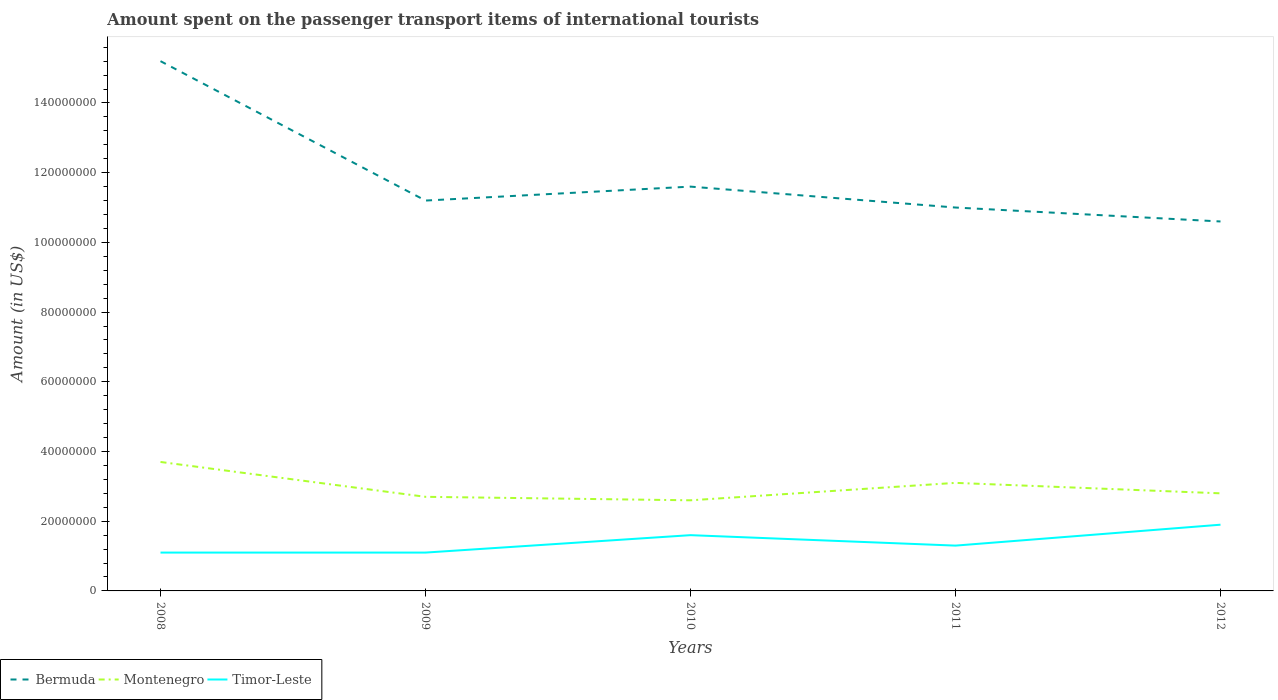How many different coloured lines are there?
Give a very brief answer. 3. Across all years, what is the maximum amount spent on the passenger transport items of international tourists in Montenegro?
Offer a terse response. 2.60e+07. What is the difference between the highest and the second highest amount spent on the passenger transport items of international tourists in Montenegro?
Ensure brevity in your answer.  1.10e+07. Is the amount spent on the passenger transport items of international tourists in Timor-Leste strictly greater than the amount spent on the passenger transport items of international tourists in Bermuda over the years?
Offer a terse response. Yes. How many lines are there?
Keep it short and to the point. 3. Are the values on the major ticks of Y-axis written in scientific E-notation?
Your response must be concise. No. Does the graph contain any zero values?
Make the answer very short. No. Does the graph contain grids?
Your answer should be compact. No. How are the legend labels stacked?
Provide a short and direct response. Horizontal. What is the title of the graph?
Provide a succinct answer. Amount spent on the passenger transport items of international tourists. Does "Ethiopia" appear as one of the legend labels in the graph?
Provide a short and direct response. No. What is the label or title of the Y-axis?
Make the answer very short. Amount (in US$). What is the Amount (in US$) in Bermuda in 2008?
Your answer should be very brief. 1.52e+08. What is the Amount (in US$) in Montenegro in 2008?
Make the answer very short. 3.70e+07. What is the Amount (in US$) in Timor-Leste in 2008?
Keep it short and to the point. 1.10e+07. What is the Amount (in US$) in Bermuda in 2009?
Your answer should be very brief. 1.12e+08. What is the Amount (in US$) in Montenegro in 2009?
Provide a short and direct response. 2.70e+07. What is the Amount (in US$) in Timor-Leste in 2009?
Your answer should be very brief. 1.10e+07. What is the Amount (in US$) of Bermuda in 2010?
Offer a terse response. 1.16e+08. What is the Amount (in US$) in Montenegro in 2010?
Provide a short and direct response. 2.60e+07. What is the Amount (in US$) of Timor-Leste in 2010?
Provide a short and direct response. 1.60e+07. What is the Amount (in US$) of Bermuda in 2011?
Provide a succinct answer. 1.10e+08. What is the Amount (in US$) of Montenegro in 2011?
Your response must be concise. 3.10e+07. What is the Amount (in US$) of Timor-Leste in 2011?
Your answer should be very brief. 1.30e+07. What is the Amount (in US$) in Bermuda in 2012?
Give a very brief answer. 1.06e+08. What is the Amount (in US$) of Montenegro in 2012?
Your answer should be very brief. 2.80e+07. What is the Amount (in US$) in Timor-Leste in 2012?
Give a very brief answer. 1.90e+07. Across all years, what is the maximum Amount (in US$) in Bermuda?
Your response must be concise. 1.52e+08. Across all years, what is the maximum Amount (in US$) of Montenegro?
Your answer should be compact. 3.70e+07. Across all years, what is the maximum Amount (in US$) in Timor-Leste?
Ensure brevity in your answer.  1.90e+07. Across all years, what is the minimum Amount (in US$) of Bermuda?
Your response must be concise. 1.06e+08. Across all years, what is the minimum Amount (in US$) of Montenegro?
Make the answer very short. 2.60e+07. Across all years, what is the minimum Amount (in US$) in Timor-Leste?
Give a very brief answer. 1.10e+07. What is the total Amount (in US$) of Bermuda in the graph?
Your answer should be very brief. 5.96e+08. What is the total Amount (in US$) in Montenegro in the graph?
Make the answer very short. 1.49e+08. What is the total Amount (in US$) of Timor-Leste in the graph?
Keep it short and to the point. 7.00e+07. What is the difference between the Amount (in US$) in Bermuda in 2008 and that in 2009?
Offer a terse response. 4.00e+07. What is the difference between the Amount (in US$) in Montenegro in 2008 and that in 2009?
Your response must be concise. 1.00e+07. What is the difference between the Amount (in US$) of Bermuda in 2008 and that in 2010?
Provide a short and direct response. 3.60e+07. What is the difference between the Amount (in US$) in Montenegro in 2008 and that in 2010?
Your answer should be very brief. 1.10e+07. What is the difference between the Amount (in US$) of Timor-Leste in 2008 and that in 2010?
Give a very brief answer. -5.00e+06. What is the difference between the Amount (in US$) in Bermuda in 2008 and that in 2011?
Your answer should be very brief. 4.20e+07. What is the difference between the Amount (in US$) in Montenegro in 2008 and that in 2011?
Your answer should be very brief. 6.00e+06. What is the difference between the Amount (in US$) in Bermuda in 2008 and that in 2012?
Your answer should be compact. 4.60e+07. What is the difference between the Amount (in US$) in Montenegro in 2008 and that in 2012?
Keep it short and to the point. 9.00e+06. What is the difference between the Amount (in US$) of Timor-Leste in 2008 and that in 2012?
Your answer should be very brief. -8.00e+06. What is the difference between the Amount (in US$) of Bermuda in 2009 and that in 2010?
Provide a short and direct response. -4.00e+06. What is the difference between the Amount (in US$) of Montenegro in 2009 and that in 2010?
Keep it short and to the point. 1.00e+06. What is the difference between the Amount (in US$) of Timor-Leste in 2009 and that in 2010?
Your response must be concise. -5.00e+06. What is the difference between the Amount (in US$) in Montenegro in 2009 and that in 2011?
Keep it short and to the point. -4.00e+06. What is the difference between the Amount (in US$) in Timor-Leste in 2009 and that in 2011?
Ensure brevity in your answer.  -2.00e+06. What is the difference between the Amount (in US$) of Timor-Leste in 2009 and that in 2012?
Your answer should be very brief. -8.00e+06. What is the difference between the Amount (in US$) in Montenegro in 2010 and that in 2011?
Offer a very short reply. -5.00e+06. What is the difference between the Amount (in US$) of Timor-Leste in 2010 and that in 2011?
Your response must be concise. 3.00e+06. What is the difference between the Amount (in US$) of Bermuda in 2010 and that in 2012?
Offer a very short reply. 1.00e+07. What is the difference between the Amount (in US$) in Montenegro in 2010 and that in 2012?
Give a very brief answer. -2.00e+06. What is the difference between the Amount (in US$) of Timor-Leste in 2010 and that in 2012?
Make the answer very short. -3.00e+06. What is the difference between the Amount (in US$) of Bermuda in 2011 and that in 2012?
Ensure brevity in your answer.  4.00e+06. What is the difference between the Amount (in US$) in Montenegro in 2011 and that in 2012?
Provide a short and direct response. 3.00e+06. What is the difference between the Amount (in US$) of Timor-Leste in 2011 and that in 2012?
Make the answer very short. -6.00e+06. What is the difference between the Amount (in US$) of Bermuda in 2008 and the Amount (in US$) of Montenegro in 2009?
Your answer should be compact. 1.25e+08. What is the difference between the Amount (in US$) in Bermuda in 2008 and the Amount (in US$) in Timor-Leste in 2009?
Your answer should be compact. 1.41e+08. What is the difference between the Amount (in US$) in Montenegro in 2008 and the Amount (in US$) in Timor-Leste in 2009?
Offer a very short reply. 2.60e+07. What is the difference between the Amount (in US$) in Bermuda in 2008 and the Amount (in US$) in Montenegro in 2010?
Keep it short and to the point. 1.26e+08. What is the difference between the Amount (in US$) of Bermuda in 2008 and the Amount (in US$) of Timor-Leste in 2010?
Offer a very short reply. 1.36e+08. What is the difference between the Amount (in US$) of Montenegro in 2008 and the Amount (in US$) of Timor-Leste in 2010?
Your answer should be compact. 2.10e+07. What is the difference between the Amount (in US$) of Bermuda in 2008 and the Amount (in US$) of Montenegro in 2011?
Offer a very short reply. 1.21e+08. What is the difference between the Amount (in US$) in Bermuda in 2008 and the Amount (in US$) in Timor-Leste in 2011?
Make the answer very short. 1.39e+08. What is the difference between the Amount (in US$) of Montenegro in 2008 and the Amount (in US$) of Timor-Leste in 2011?
Make the answer very short. 2.40e+07. What is the difference between the Amount (in US$) in Bermuda in 2008 and the Amount (in US$) in Montenegro in 2012?
Your answer should be compact. 1.24e+08. What is the difference between the Amount (in US$) in Bermuda in 2008 and the Amount (in US$) in Timor-Leste in 2012?
Keep it short and to the point. 1.33e+08. What is the difference between the Amount (in US$) of Montenegro in 2008 and the Amount (in US$) of Timor-Leste in 2012?
Keep it short and to the point. 1.80e+07. What is the difference between the Amount (in US$) of Bermuda in 2009 and the Amount (in US$) of Montenegro in 2010?
Provide a succinct answer. 8.60e+07. What is the difference between the Amount (in US$) of Bermuda in 2009 and the Amount (in US$) of Timor-Leste in 2010?
Keep it short and to the point. 9.60e+07. What is the difference between the Amount (in US$) in Montenegro in 2009 and the Amount (in US$) in Timor-Leste in 2010?
Keep it short and to the point. 1.10e+07. What is the difference between the Amount (in US$) of Bermuda in 2009 and the Amount (in US$) of Montenegro in 2011?
Offer a terse response. 8.10e+07. What is the difference between the Amount (in US$) of Bermuda in 2009 and the Amount (in US$) of Timor-Leste in 2011?
Keep it short and to the point. 9.90e+07. What is the difference between the Amount (in US$) in Montenegro in 2009 and the Amount (in US$) in Timor-Leste in 2011?
Make the answer very short. 1.40e+07. What is the difference between the Amount (in US$) of Bermuda in 2009 and the Amount (in US$) of Montenegro in 2012?
Ensure brevity in your answer.  8.40e+07. What is the difference between the Amount (in US$) of Bermuda in 2009 and the Amount (in US$) of Timor-Leste in 2012?
Provide a succinct answer. 9.30e+07. What is the difference between the Amount (in US$) of Bermuda in 2010 and the Amount (in US$) of Montenegro in 2011?
Keep it short and to the point. 8.50e+07. What is the difference between the Amount (in US$) in Bermuda in 2010 and the Amount (in US$) in Timor-Leste in 2011?
Your response must be concise. 1.03e+08. What is the difference between the Amount (in US$) in Montenegro in 2010 and the Amount (in US$) in Timor-Leste in 2011?
Give a very brief answer. 1.30e+07. What is the difference between the Amount (in US$) in Bermuda in 2010 and the Amount (in US$) in Montenegro in 2012?
Your answer should be compact. 8.80e+07. What is the difference between the Amount (in US$) in Bermuda in 2010 and the Amount (in US$) in Timor-Leste in 2012?
Keep it short and to the point. 9.70e+07. What is the difference between the Amount (in US$) of Montenegro in 2010 and the Amount (in US$) of Timor-Leste in 2012?
Keep it short and to the point. 7.00e+06. What is the difference between the Amount (in US$) in Bermuda in 2011 and the Amount (in US$) in Montenegro in 2012?
Your answer should be very brief. 8.20e+07. What is the difference between the Amount (in US$) in Bermuda in 2011 and the Amount (in US$) in Timor-Leste in 2012?
Ensure brevity in your answer.  9.10e+07. What is the difference between the Amount (in US$) of Montenegro in 2011 and the Amount (in US$) of Timor-Leste in 2012?
Give a very brief answer. 1.20e+07. What is the average Amount (in US$) of Bermuda per year?
Offer a terse response. 1.19e+08. What is the average Amount (in US$) in Montenegro per year?
Offer a terse response. 2.98e+07. What is the average Amount (in US$) in Timor-Leste per year?
Provide a short and direct response. 1.40e+07. In the year 2008, what is the difference between the Amount (in US$) of Bermuda and Amount (in US$) of Montenegro?
Ensure brevity in your answer.  1.15e+08. In the year 2008, what is the difference between the Amount (in US$) in Bermuda and Amount (in US$) in Timor-Leste?
Ensure brevity in your answer.  1.41e+08. In the year 2008, what is the difference between the Amount (in US$) in Montenegro and Amount (in US$) in Timor-Leste?
Offer a terse response. 2.60e+07. In the year 2009, what is the difference between the Amount (in US$) in Bermuda and Amount (in US$) in Montenegro?
Ensure brevity in your answer.  8.50e+07. In the year 2009, what is the difference between the Amount (in US$) of Bermuda and Amount (in US$) of Timor-Leste?
Keep it short and to the point. 1.01e+08. In the year 2009, what is the difference between the Amount (in US$) of Montenegro and Amount (in US$) of Timor-Leste?
Give a very brief answer. 1.60e+07. In the year 2010, what is the difference between the Amount (in US$) in Bermuda and Amount (in US$) in Montenegro?
Provide a short and direct response. 9.00e+07. In the year 2010, what is the difference between the Amount (in US$) of Montenegro and Amount (in US$) of Timor-Leste?
Offer a terse response. 1.00e+07. In the year 2011, what is the difference between the Amount (in US$) in Bermuda and Amount (in US$) in Montenegro?
Keep it short and to the point. 7.90e+07. In the year 2011, what is the difference between the Amount (in US$) of Bermuda and Amount (in US$) of Timor-Leste?
Make the answer very short. 9.70e+07. In the year 2011, what is the difference between the Amount (in US$) in Montenegro and Amount (in US$) in Timor-Leste?
Your answer should be very brief. 1.80e+07. In the year 2012, what is the difference between the Amount (in US$) in Bermuda and Amount (in US$) in Montenegro?
Your response must be concise. 7.80e+07. In the year 2012, what is the difference between the Amount (in US$) in Bermuda and Amount (in US$) in Timor-Leste?
Make the answer very short. 8.70e+07. In the year 2012, what is the difference between the Amount (in US$) in Montenegro and Amount (in US$) in Timor-Leste?
Offer a terse response. 9.00e+06. What is the ratio of the Amount (in US$) of Bermuda in 2008 to that in 2009?
Offer a terse response. 1.36. What is the ratio of the Amount (in US$) in Montenegro in 2008 to that in 2009?
Offer a terse response. 1.37. What is the ratio of the Amount (in US$) in Timor-Leste in 2008 to that in 2009?
Offer a terse response. 1. What is the ratio of the Amount (in US$) in Bermuda in 2008 to that in 2010?
Offer a very short reply. 1.31. What is the ratio of the Amount (in US$) in Montenegro in 2008 to that in 2010?
Provide a succinct answer. 1.42. What is the ratio of the Amount (in US$) in Timor-Leste in 2008 to that in 2010?
Provide a short and direct response. 0.69. What is the ratio of the Amount (in US$) of Bermuda in 2008 to that in 2011?
Your answer should be compact. 1.38. What is the ratio of the Amount (in US$) in Montenegro in 2008 to that in 2011?
Offer a terse response. 1.19. What is the ratio of the Amount (in US$) of Timor-Leste in 2008 to that in 2011?
Make the answer very short. 0.85. What is the ratio of the Amount (in US$) in Bermuda in 2008 to that in 2012?
Offer a terse response. 1.43. What is the ratio of the Amount (in US$) of Montenegro in 2008 to that in 2012?
Offer a terse response. 1.32. What is the ratio of the Amount (in US$) in Timor-Leste in 2008 to that in 2012?
Keep it short and to the point. 0.58. What is the ratio of the Amount (in US$) of Bermuda in 2009 to that in 2010?
Offer a terse response. 0.97. What is the ratio of the Amount (in US$) of Montenegro in 2009 to that in 2010?
Make the answer very short. 1.04. What is the ratio of the Amount (in US$) of Timor-Leste in 2009 to that in 2010?
Ensure brevity in your answer.  0.69. What is the ratio of the Amount (in US$) of Bermuda in 2009 to that in 2011?
Offer a terse response. 1.02. What is the ratio of the Amount (in US$) of Montenegro in 2009 to that in 2011?
Offer a very short reply. 0.87. What is the ratio of the Amount (in US$) in Timor-Leste in 2009 to that in 2011?
Your answer should be very brief. 0.85. What is the ratio of the Amount (in US$) of Bermuda in 2009 to that in 2012?
Ensure brevity in your answer.  1.06. What is the ratio of the Amount (in US$) of Timor-Leste in 2009 to that in 2012?
Offer a terse response. 0.58. What is the ratio of the Amount (in US$) in Bermuda in 2010 to that in 2011?
Keep it short and to the point. 1.05. What is the ratio of the Amount (in US$) of Montenegro in 2010 to that in 2011?
Your answer should be compact. 0.84. What is the ratio of the Amount (in US$) of Timor-Leste in 2010 to that in 2011?
Offer a terse response. 1.23. What is the ratio of the Amount (in US$) in Bermuda in 2010 to that in 2012?
Your answer should be compact. 1.09. What is the ratio of the Amount (in US$) of Montenegro in 2010 to that in 2012?
Offer a terse response. 0.93. What is the ratio of the Amount (in US$) of Timor-Leste in 2010 to that in 2012?
Your response must be concise. 0.84. What is the ratio of the Amount (in US$) of Bermuda in 2011 to that in 2012?
Your answer should be compact. 1.04. What is the ratio of the Amount (in US$) of Montenegro in 2011 to that in 2012?
Offer a terse response. 1.11. What is the ratio of the Amount (in US$) of Timor-Leste in 2011 to that in 2012?
Your answer should be very brief. 0.68. What is the difference between the highest and the second highest Amount (in US$) of Bermuda?
Make the answer very short. 3.60e+07. What is the difference between the highest and the lowest Amount (in US$) of Bermuda?
Make the answer very short. 4.60e+07. What is the difference between the highest and the lowest Amount (in US$) of Montenegro?
Provide a short and direct response. 1.10e+07. What is the difference between the highest and the lowest Amount (in US$) of Timor-Leste?
Offer a terse response. 8.00e+06. 